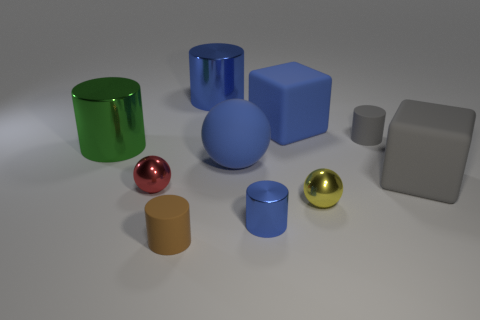Is there anything else that has the same shape as the brown matte object?
Provide a succinct answer. Yes. There is another large rubber thing that is the same shape as the big gray thing; what is its color?
Ensure brevity in your answer.  Blue. What number of things are either metallic cubes or tiny rubber things that are in front of the big gray cube?
Offer a very short reply. 1. Are there fewer things that are left of the red ball than green cylinders?
Keep it short and to the point. No. How big is the metal ball on the right side of the rubber cylinder that is in front of the gray matte thing in front of the green cylinder?
Provide a succinct answer. Small. The big thing that is in front of the tiny gray cylinder and on the right side of the tiny blue metallic thing is what color?
Keep it short and to the point. Gray. What number of big green cylinders are there?
Provide a short and direct response. 1. Is there anything else that has the same size as the blue cube?
Give a very brief answer. Yes. Does the red ball have the same material as the large blue cylinder?
Your answer should be compact. Yes. Is the size of the thing on the left side of the red object the same as the sphere that is behind the large gray matte object?
Provide a succinct answer. Yes. 